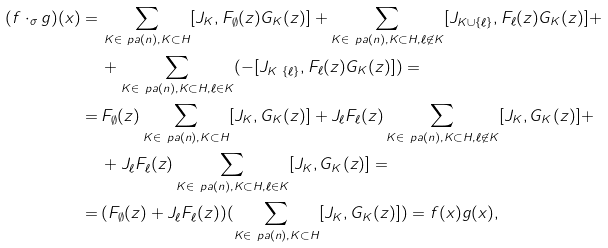Convert formula to latex. <formula><loc_0><loc_0><loc_500><loc_500>( f \cdot _ { \sigma } g ) ( x ) = \, & \sum _ { K \in \ p a ( n ) , K \subset H } [ J _ { K } , F _ { \emptyset } ( z ) G _ { K } ( z ) ] + \sum _ { K \in \ p a ( n ) , K \subset H , \ell \not \in K } [ J _ { K \cup \{ \ell \} } , F _ { \ell } ( z ) G _ { K } ( z ) ] + \\ & + \sum _ { K \in \ p a ( n ) , K \subset H , \ell \in K } ( - [ J _ { K \ \{ \ell \} } , F _ { \ell } ( z ) G _ { K } ( z ) ] ) = \\ = \, & F _ { \emptyset } ( z ) \sum _ { K \in \ p a ( n ) , K \subset H } [ J _ { K } , G _ { K } ( z ) ] + J _ { \ell } F _ { \ell } ( z ) \sum _ { K \in \ p a ( n ) , K \subset H , \ell \not \in K } [ J _ { K } , G _ { K } ( z ) ] + \\ & + J _ { \ell } F _ { \ell } ( z ) \sum _ { K \in \ p a ( n ) , K \subset H , \ell \in K } [ J _ { K } , G _ { K } ( z ) ] = \\ = \, & ( F _ { \emptyset } ( z ) + J _ { \ell } F _ { \ell } ( z ) ) ( \sum _ { K \in \ p a ( n ) , K \subset H } [ J _ { K } , G _ { K } ( z ) ] ) = f ( x ) g ( x ) ,</formula> 